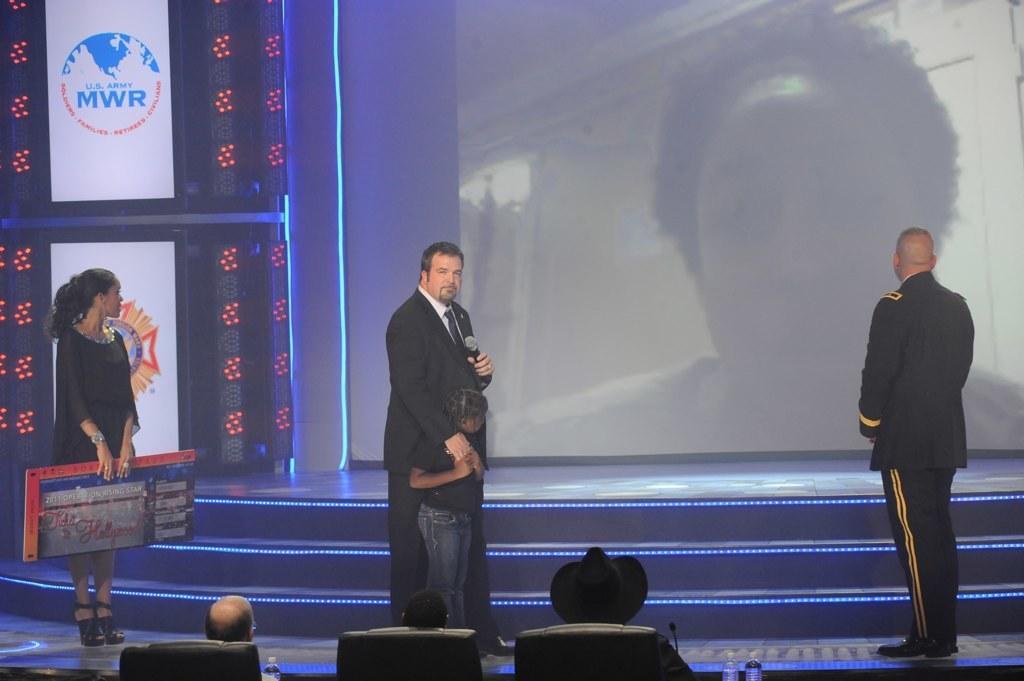Please provide a concise description of this image. At the bottom of the image we can see a few people are sitting on the chairs. Among them, we can see one person is wearing a black hat. In front of them, we can see one microphone, water bottles and a few other objects. In the center of the image, we can see one stage, lights, staircase and a few other objects. On the stage, we can see a few people are standing. Among them, we can see one person is holding a microphone and the other person is holding a banner. In the background we can see one screen, banners, lights and a few other objects. 